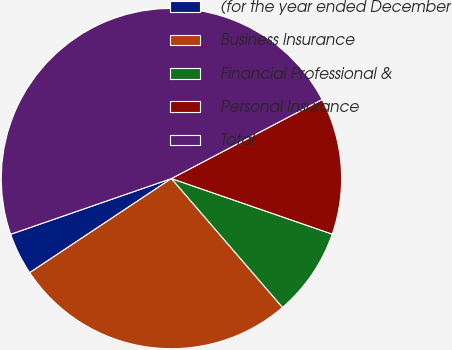Convert chart to OTSL. <chart><loc_0><loc_0><loc_500><loc_500><pie_chart><fcel>(for the year ended December<fcel>Business Insurance<fcel>Financial Professional &<fcel>Personal Insurance<fcel>Total<nl><fcel>4.02%<fcel>26.99%<fcel>8.38%<fcel>12.99%<fcel>47.62%<nl></chart> 